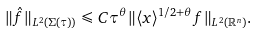<formula> <loc_0><loc_0><loc_500><loc_500>\| \hat { f } \| _ { L ^ { 2 } ( \Sigma ( \tau ) ) } \leqslant C \tau ^ { \theta } \| \langle { x } \rangle ^ { 1 / 2 + \theta } f \| _ { L ^ { 2 } ( \mathbb { R } ^ { n } ) } .</formula> 